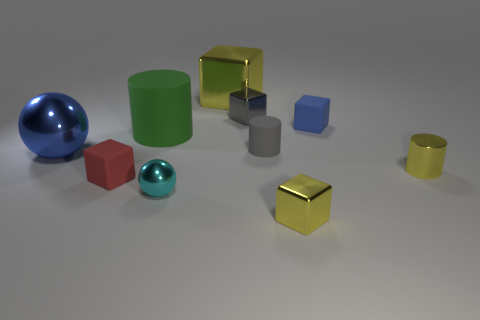Subtract all tiny metal blocks. How many blocks are left? 3 Subtract all green balls. How many yellow cubes are left? 2 Subtract 1 cylinders. How many cylinders are left? 2 Subtract all blue blocks. How many blocks are left? 4 Subtract all brown blocks. Subtract all blue balls. How many blocks are left? 5 Subtract all balls. How many objects are left? 8 Subtract 0 purple cylinders. How many objects are left? 10 Subtract all large cyan cylinders. Subtract all large yellow metallic objects. How many objects are left? 9 Add 5 big matte cylinders. How many big matte cylinders are left? 6 Add 9 cyan metallic spheres. How many cyan metallic spheres exist? 10 